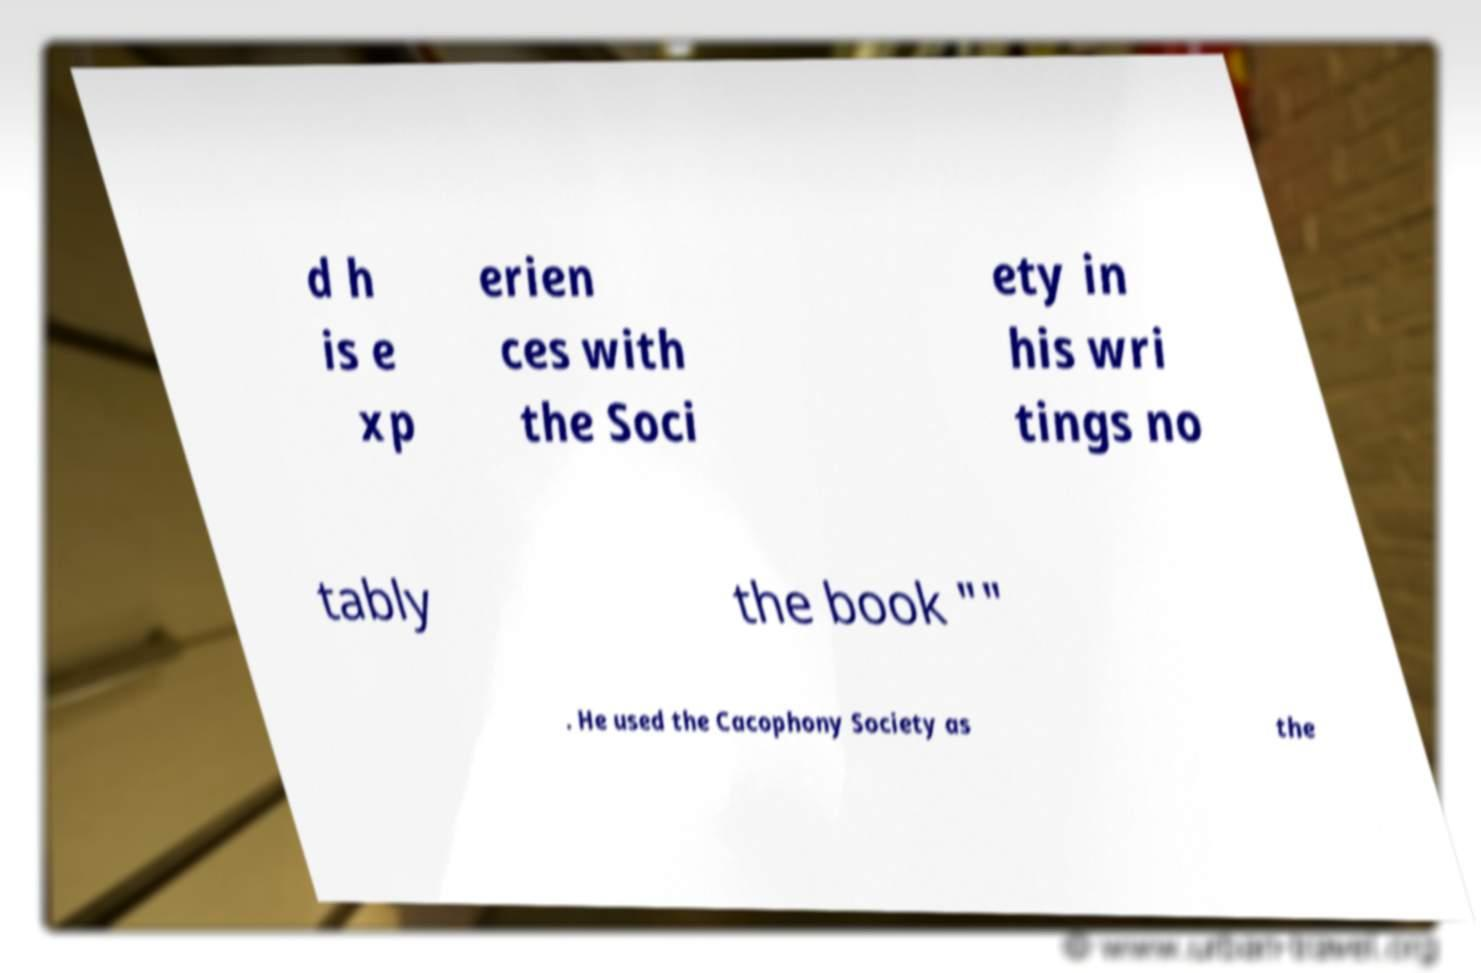There's text embedded in this image that I need extracted. Can you transcribe it verbatim? d h is e xp erien ces with the Soci ety in his wri tings no tably the book "" . He used the Cacophony Society as the 